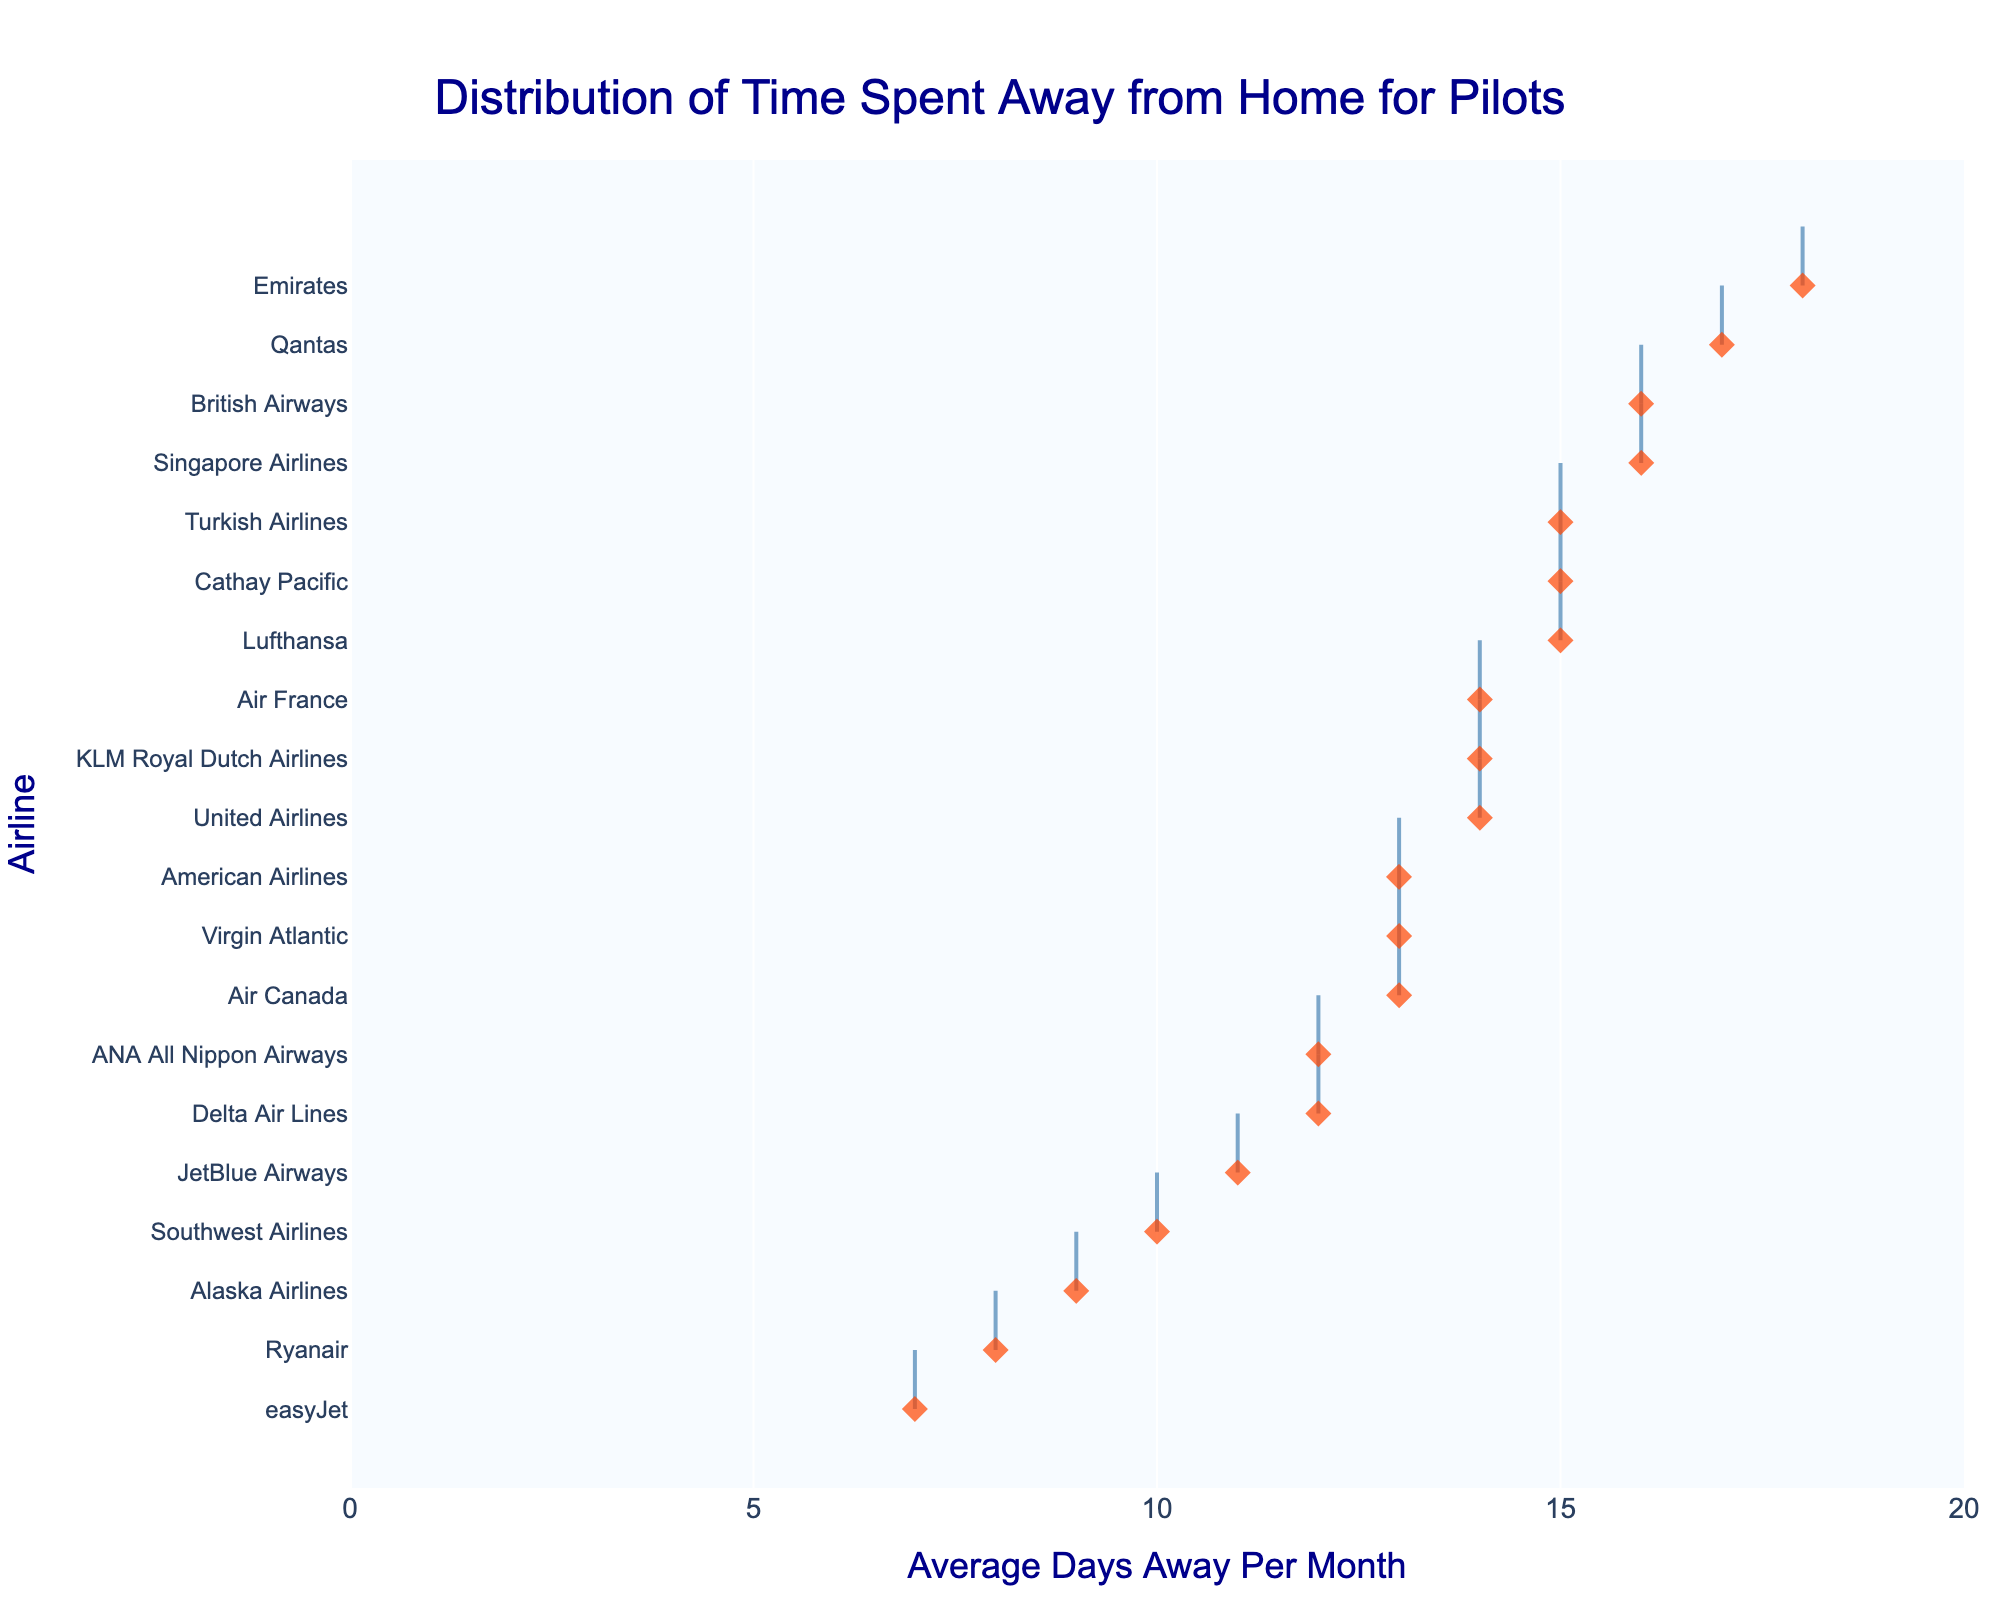How many airlines have pilots spending an average of more than 15 days away from home per month? Look at the x-axis values corresponding to the airlines on the plot. Count the number of airlines with average days away greater than 15.
Answer: 5 Which airline has pilots spending the least number of days away from home per month? Identify the airline at the left-most end of the plot which corresponds to the minimum value on the x-axis.
Answer: easyJet What's the average number of days pilots spend away from home for American Airlines and United Airlines combined? Find the values for American Airlines (13 days) and United Airlines (14 days). Calculate their average: (13 + 14) / 2 = 13.5.
Answer: 13.5 Among Delta Air Lines and ANA All Nippon Airways, which airline's pilots spend more days away from home on average? Compare the x-axis values for Delta Air Lines (12 days) and ANA All Nippon Airways (12 days). They are the same in this case.
Answer: They are equal Which airline's pilots spend more time away from home, Air Canada or British Airways? Locate Air Canada (13 days) and British Airways (16 days) on the plot, and compare their values on the x-axis.
Answer: British Airways How many airlines have pilots spending 14 days away from home per month? Count the number of airlines whose data points align with the 14 days mark on the x-axis.
Answer: 4 What is the difference in the average time spent away from home between Emirates and Ryanair pilots? Determine the x-axis values for Emirates (18 days) and Ryanair (8 days). Calculate the difference: 18 - 8 = 10.
Answer: 10 Which airlines have pilots spending exactly 15 days away from home on average? Identify the airlines whose data points align with the 15 days mark on the x-axis.
Answer: Lufthansa, Cathay Pacific, Turkish Airlines What's the range of the average days spent away from home across all airlines shown in the plot? Find the maximum value (18 days for Emirates) and the minimum value (7 days for easyJet) on the x-axis. Calculate the range: 18 - 7 = 11.
Answer: 11 On average, do JetBlue Airways pilots spend more or less time away from home compared to Alaska Airlines pilots? Locate JetBlue Airways (11 days) and Alaska Airlines (9 days) on the plot and compare their x-axis values.
Answer: More 